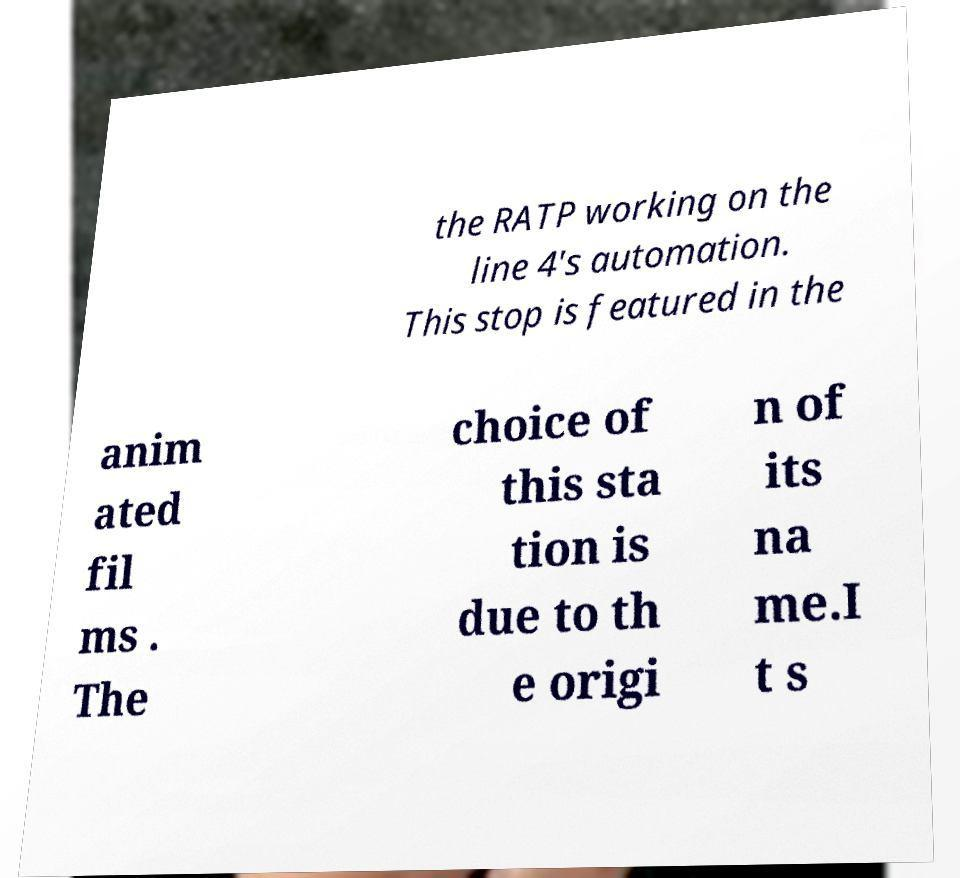What messages or text are displayed in this image? I need them in a readable, typed format. the RATP working on the line 4's automation. This stop is featured in the anim ated fil ms . The choice of this sta tion is due to th e origi n of its na me.I t s 